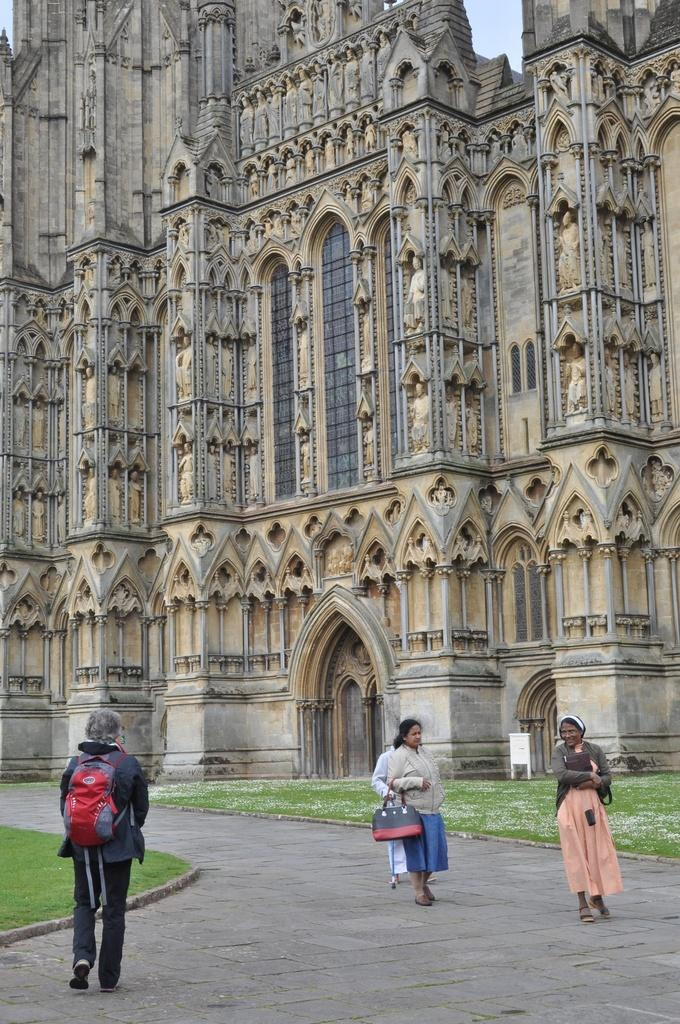What type of structure is visible in the image? There is a building in the image. What type of vegetation can be seen in the image? There is grass in the image. What are the people in the image doing? The people are standing in the image. What might the people be carrying? The people are carrying bags. Can you tell me what the people are reading in the image? There is no indication in the image that the people are reading anything. What type of stone is visible in the image? There is no stone present in the image. 